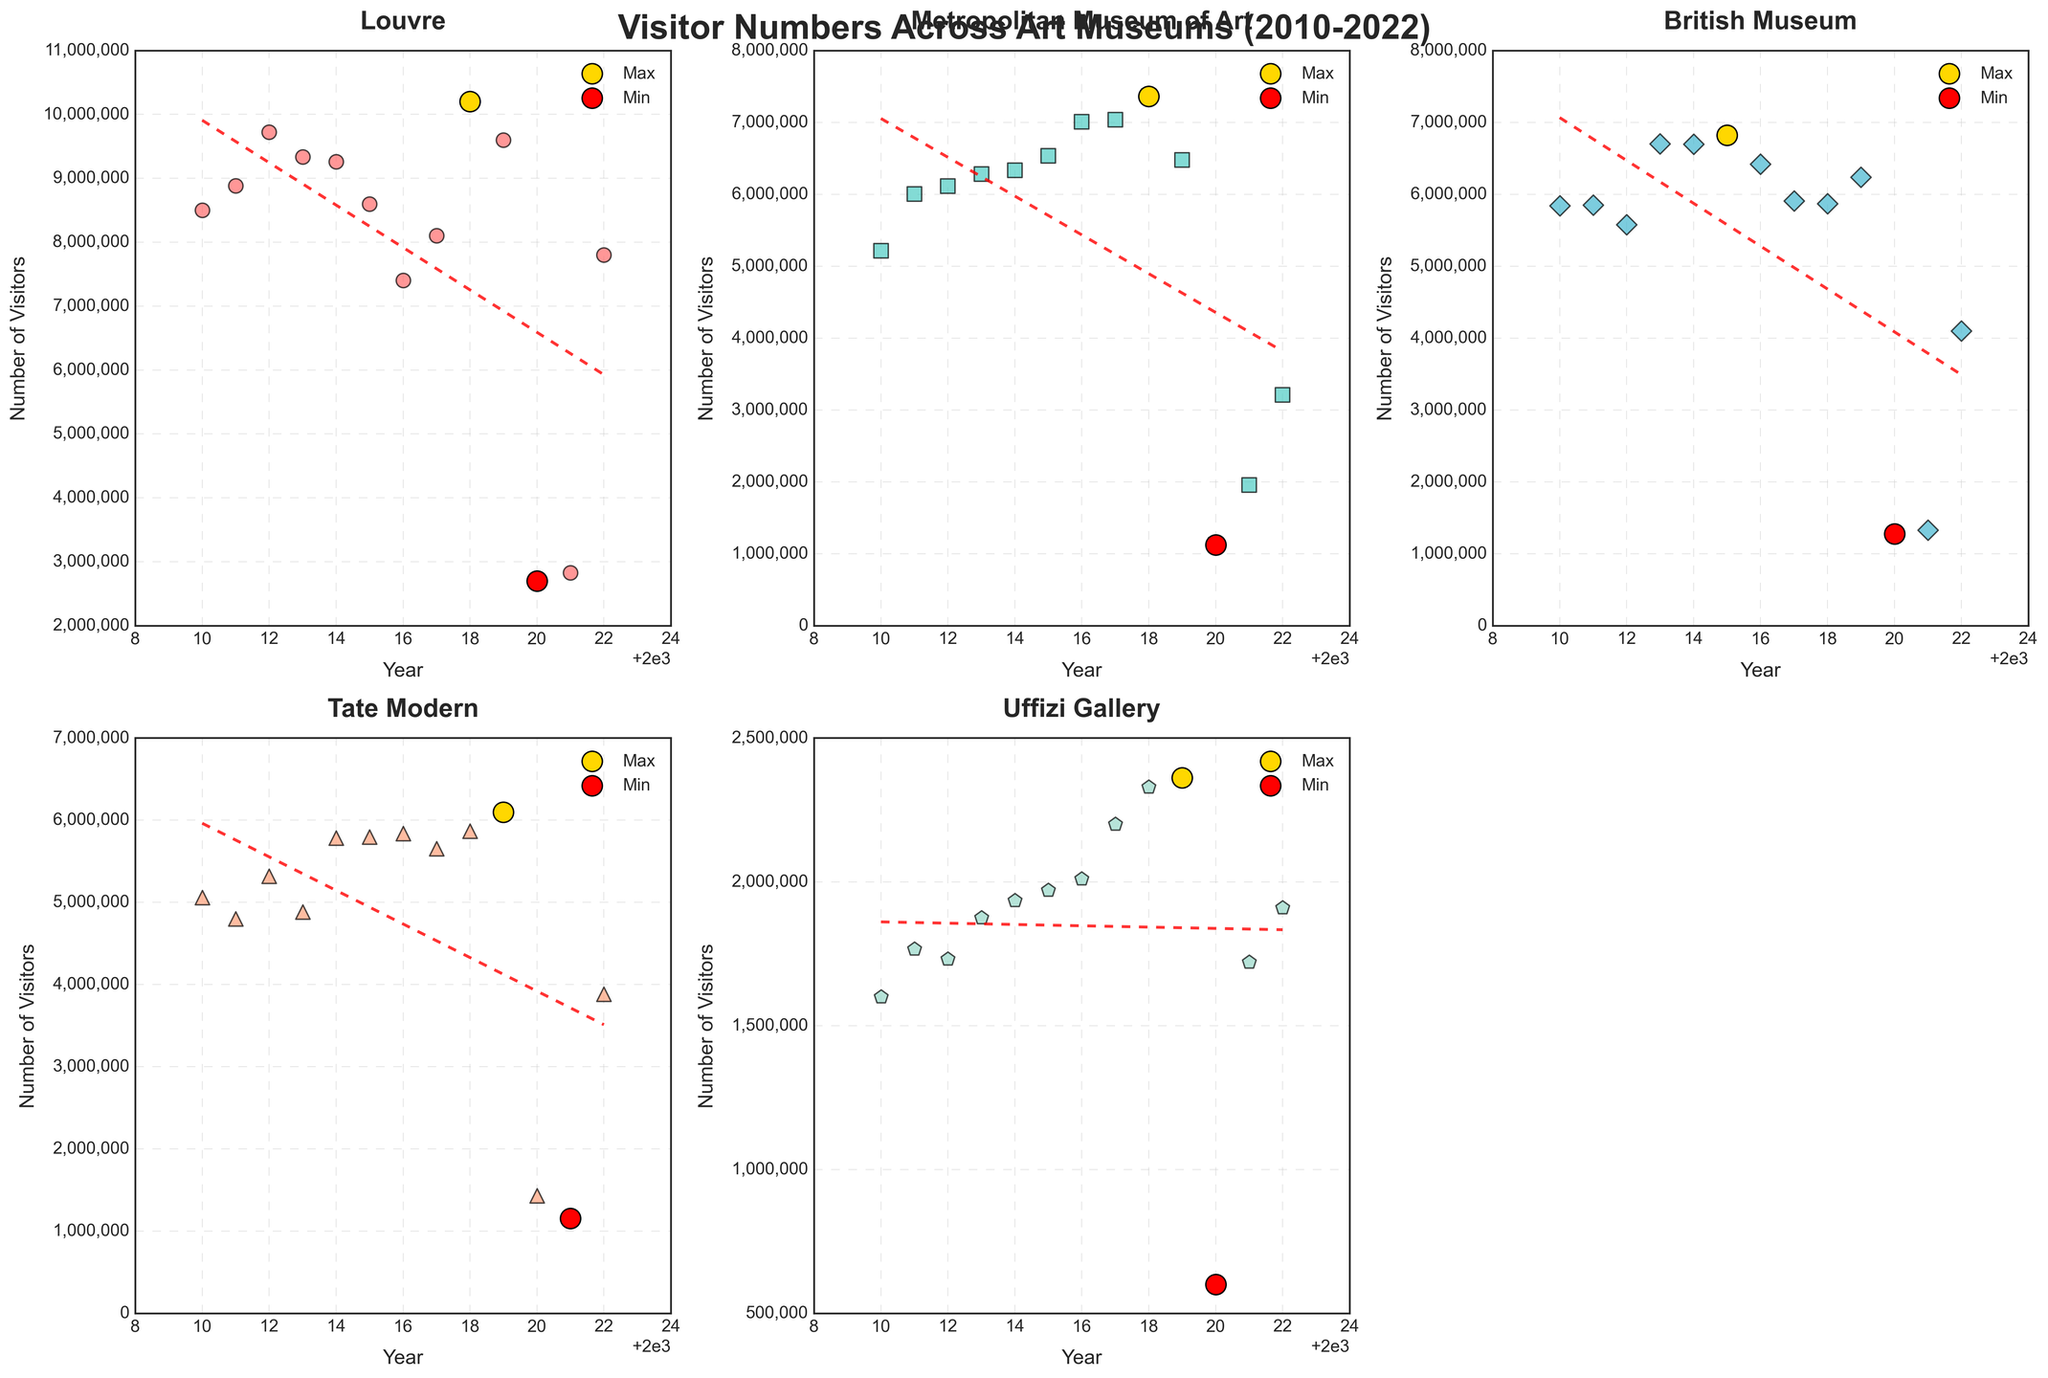Which museum had the highest number of visitors in 2018? In the subplot for each museum, look for the year 2018 and find the museum with the highest visitor count. The Louvre had about 10.2 million visitors in 2018 which is higher than any other museum.
Answer: Louvre Which year saw the least number of visitors to Tate Modern? In the subplot for Tate Modern, identify the smallest point highlighted in red. The year is 2021, with around 1.12 million visitors.
Answer: 2021 What is the average visitor count for the British Museum from 2010 to 2014? Sum the visitor numbers from 2010 to 2014: (5,842,000 + 5,848,000 + 5,575,000 + 6,701,000 + 6,695,000) = 30,661,000. Divide by 5 to get the average: 30,661,000 / 5 = 6,132,200.
Answer: 6,132,200 In which year did the Metropolitan Museum of Art experience its highest visitor number? Look at the emphasized gold-colored point on the Metropolitan Museum's subplot, which represents the maximum value. The year is 2018, with around 7.36 million visitors.
Answer: 2018 Which museum had the greatest decline in visitors between 2019 and 2020? Compare the visitor counts between 2019 and 2020 for all museums. The Louvre dropped from 9.6 million to 2.7 million, a decrease of 6.9 million. No other museum experienced a greater decline.
Answer: Louvre What is the general trend observed for the Uffizi Gallery's visitor numbers from 2010 to 2022? Examine the trend line in the subplot for the Uffizi Gallery. The overall trend shows a gradual increase in visitor numbers from 2010 to 2019, followed by a sharp decline in 2020 and 2021, and a rebound in 2022.
Answer: Increasing, then declining, then rebounding Comparing the year 2022, which museum had more visitors: the Louvre or the British Museum? Identify the visitor numbers for both museums in 2022. The Louvre had 7.8 million visitors, whereas the British Museum had 4.097 million visitors.
Answer: Louvre What is the difference between the maximum number of visitors to the Tate Modern and the minimum number of visitors to the Uffizi Gallery? Find the maximum visitor number for Tate Modern (6.098 million in 2019) and the minimum for Uffizi Gallery (600,000 in 2020). The difference is: 6,098,000 - 600,000 = 5,498,000.
Answer: 5,498,000 Which museum had a steady increase in visitors from 2010 to 2016? Check the subplots for each museum for a consistent upward trend in visitor numbers from 2010 to 2016. The Metropolitan Museum of Art shows a steady increase during this period.
Answer: Metropolitan Museum of Art 